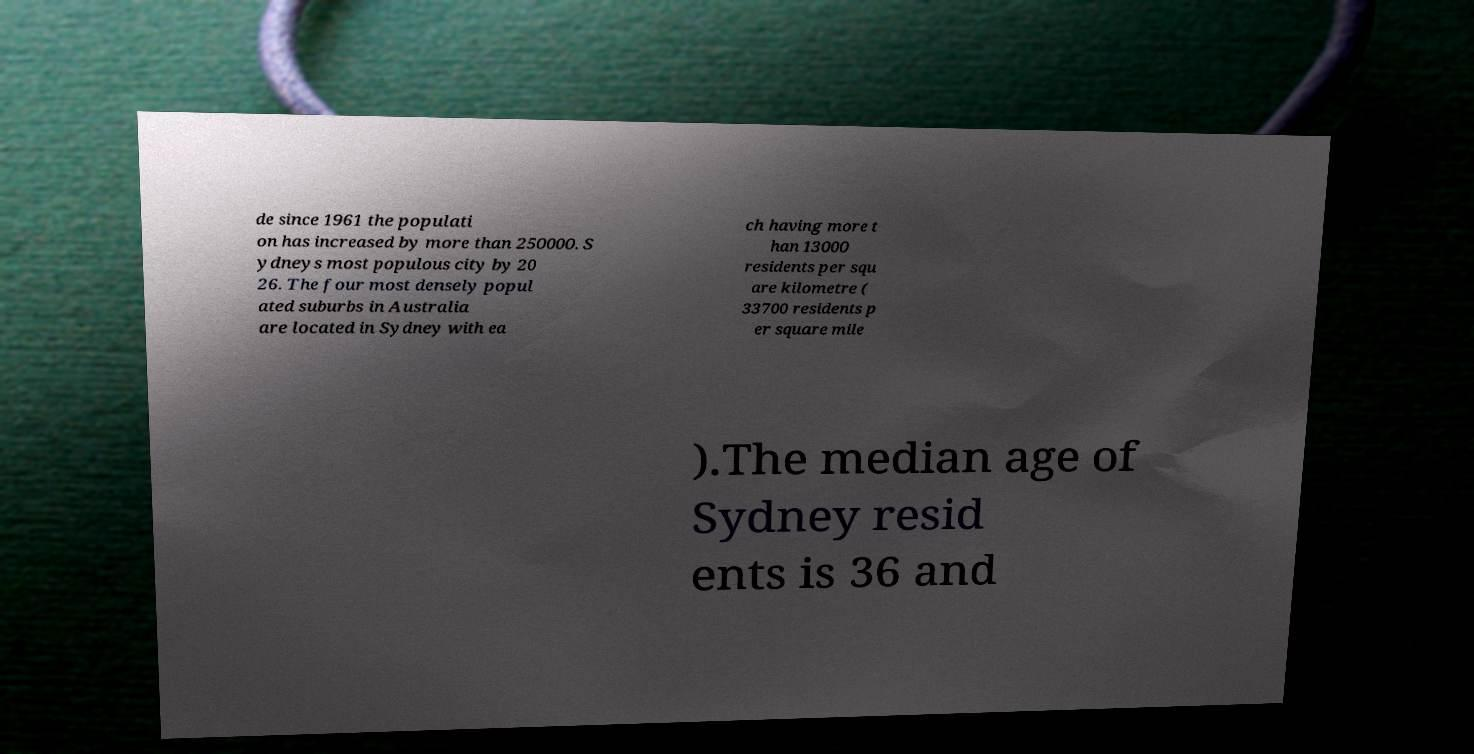Please identify and transcribe the text found in this image. de since 1961 the populati on has increased by more than 250000. S ydneys most populous city by 20 26. The four most densely popul ated suburbs in Australia are located in Sydney with ea ch having more t han 13000 residents per squ are kilometre ( 33700 residents p er square mile ).The median age of Sydney resid ents is 36 and 